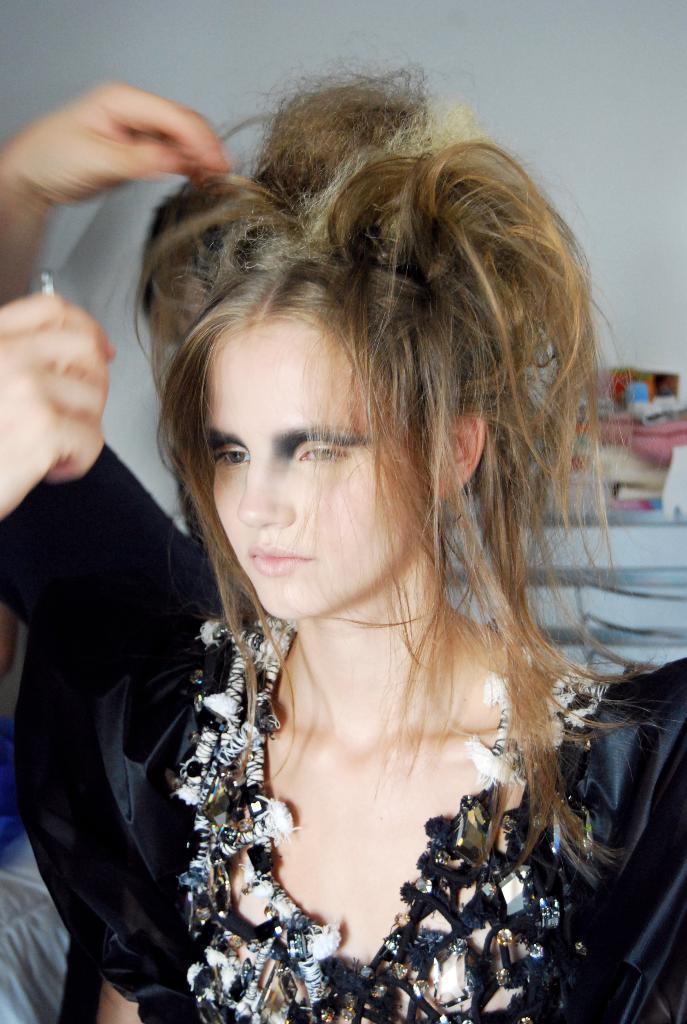Can you describe this image briefly? In this image we can see there is a girl wearing black dress is looking to the left side of the image. 